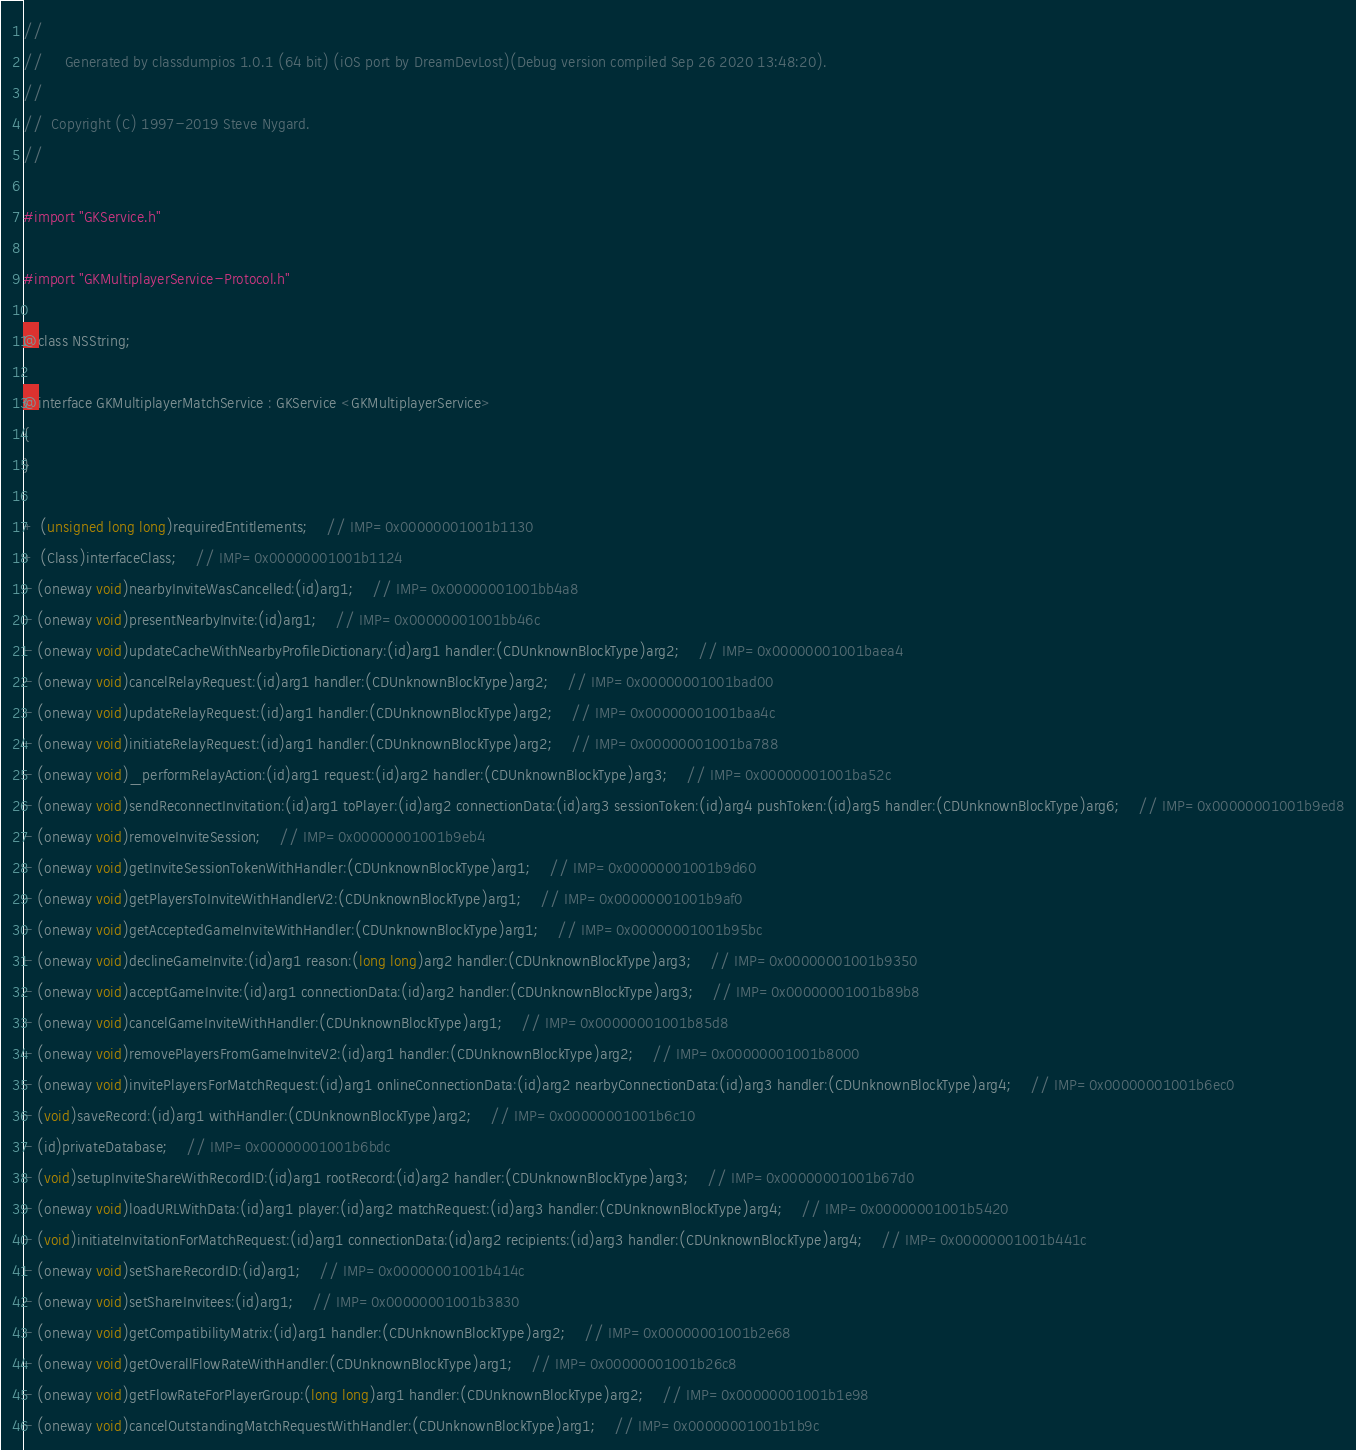<code> <loc_0><loc_0><loc_500><loc_500><_C_>//
//     Generated by classdumpios 1.0.1 (64 bit) (iOS port by DreamDevLost)(Debug version compiled Sep 26 2020 13:48:20).
//
//  Copyright (C) 1997-2019 Steve Nygard.
//

#import "GKService.h"

#import "GKMultiplayerService-Protocol.h"

@class NSString;

@interface GKMultiplayerMatchService : GKService <GKMultiplayerService>
{
}

+ (unsigned long long)requiredEntitlements;	// IMP=0x00000001001b1130
+ (Class)interfaceClass;	// IMP=0x00000001001b1124
- (oneway void)nearbyInviteWasCancelled:(id)arg1;	// IMP=0x00000001001bb4a8
- (oneway void)presentNearbyInvite:(id)arg1;	// IMP=0x00000001001bb46c
- (oneway void)updateCacheWithNearbyProfileDictionary:(id)arg1 handler:(CDUnknownBlockType)arg2;	// IMP=0x00000001001baea4
- (oneway void)cancelRelayRequest:(id)arg1 handler:(CDUnknownBlockType)arg2;	// IMP=0x00000001001bad00
- (oneway void)updateRelayRequest:(id)arg1 handler:(CDUnknownBlockType)arg2;	// IMP=0x00000001001baa4c
- (oneway void)initiateRelayRequest:(id)arg1 handler:(CDUnknownBlockType)arg2;	// IMP=0x00000001001ba788
- (oneway void)_performRelayAction:(id)arg1 request:(id)arg2 handler:(CDUnknownBlockType)arg3;	// IMP=0x00000001001ba52c
- (oneway void)sendReconnectInvitation:(id)arg1 toPlayer:(id)arg2 connectionData:(id)arg3 sessionToken:(id)arg4 pushToken:(id)arg5 handler:(CDUnknownBlockType)arg6;	// IMP=0x00000001001b9ed8
- (oneway void)removeInviteSession;	// IMP=0x00000001001b9eb4
- (oneway void)getInviteSessionTokenWithHandler:(CDUnknownBlockType)arg1;	// IMP=0x00000001001b9d60
- (oneway void)getPlayersToInviteWithHandlerV2:(CDUnknownBlockType)arg1;	// IMP=0x00000001001b9af0
- (oneway void)getAcceptedGameInviteWithHandler:(CDUnknownBlockType)arg1;	// IMP=0x00000001001b95bc
- (oneway void)declineGameInvite:(id)arg1 reason:(long long)arg2 handler:(CDUnknownBlockType)arg3;	// IMP=0x00000001001b9350
- (oneway void)acceptGameInvite:(id)arg1 connectionData:(id)arg2 handler:(CDUnknownBlockType)arg3;	// IMP=0x00000001001b89b8
- (oneway void)cancelGameInviteWithHandler:(CDUnknownBlockType)arg1;	// IMP=0x00000001001b85d8
- (oneway void)removePlayersFromGameInviteV2:(id)arg1 handler:(CDUnknownBlockType)arg2;	// IMP=0x00000001001b8000
- (oneway void)invitePlayersForMatchRequest:(id)arg1 onlineConnectionData:(id)arg2 nearbyConnectionData:(id)arg3 handler:(CDUnknownBlockType)arg4;	// IMP=0x00000001001b6ec0
- (void)saveRecord:(id)arg1 withHandler:(CDUnknownBlockType)arg2;	// IMP=0x00000001001b6c10
- (id)privateDatabase;	// IMP=0x00000001001b6bdc
- (void)setupInviteShareWithRecordID:(id)arg1 rootRecord:(id)arg2 handler:(CDUnknownBlockType)arg3;	// IMP=0x00000001001b67d0
- (oneway void)loadURLWithData:(id)arg1 player:(id)arg2 matchRequest:(id)arg3 handler:(CDUnknownBlockType)arg4;	// IMP=0x00000001001b5420
- (void)initiateInvitationForMatchRequest:(id)arg1 connectionData:(id)arg2 recipients:(id)arg3 handler:(CDUnknownBlockType)arg4;	// IMP=0x00000001001b441c
- (oneway void)setShareRecordID:(id)arg1;	// IMP=0x00000001001b414c
- (oneway void)setShareInvitees:(id)arg1;	// IMP=0x00000001001b3830
- (oneway void)getCompatibilityMatrix:(id)arg1 handler:(CDUnknownBlockType)arg2;	// IMP=0x00000001001b2e68
- (oneway void)getOverallFlowRateWithHandler:(CDUnknownBlockType)arg1;	// IMP=0x00000001001b26c8
- (oneway void)getFlowRateForPlayerGroup:(long long)arg1 handler:(CDUnknownBlockType)arg2;	// IMP=0x00000001001b1e98
- (oneway void)cancelOutstandingMatchRequestWithHandler:(CDUnknownBlockType)arg1;	// IMP=0x00000001001b1b9c</code> 